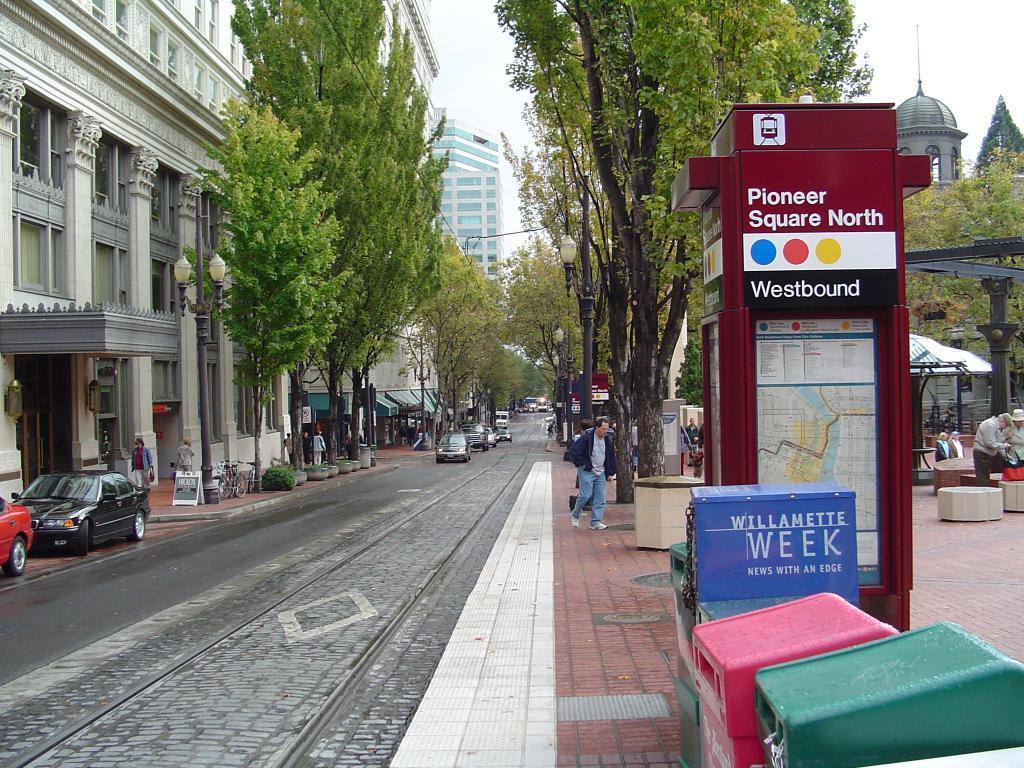Could you give a brief overview of what you see in this image? In this image I can see number of vehicles on road. I can also see number of trees, few buildings, few poles, few street lights and I can also see few people are standing. Here I can see few different colour of things and I can also see something is written over here. 